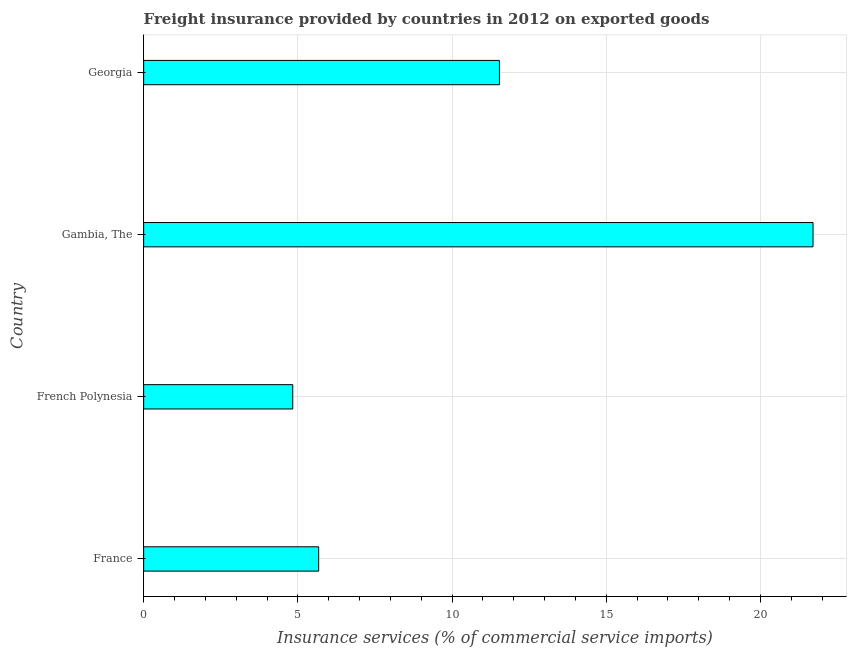Does the graph contain grids?
Give a very brief answer. Yes. What is the title of the graph?
Keep it short and to the point. Freight insurance provided by countries in 2012 on exported goods . What is the label or title of the X-axis?
Provide a succinct answer. Insurance services (% of commercial service imports). What is the freight insurance in France?
Your response must be concise. 5.68. Across all countries, what is the maximum freight insurance?
Keep it short and to the point. 21.7. Across all countries, what is the minimum freight insurance?
Your answer should be compact. 4.83. In which country was the freight insurance maximum?
Provide a short and direct response. Gambia, The. In which country was the freight insurance minimum?
Provide a succinct answer. French Polynesia. What is the sum of the freight insurance?
Your answer should be compact. 43.75. What is the difference between the freight insurance in French Polynesia and Georgia?
Ensure brevity in your answer.  -6.7. What is the average freight insurance per country?
Make the answer very short. 10.94. What is the median freight insurance?
Your answer should be compact. 8.61. What is the ratio of the freight insurance in French Polynesia to that in Georgia?
Give a very brief answer. 0.42. Is the difference between the freight insurance in French Polynesia and Georgia greater than the difference between any two countries?
Provide a succinct answer. No. What is the difference between the highest and the second highest freight insurance?
Your answer should be compact. 10.17. Is the sum of the freight insurance in Gambia, The and Georgia greater than the maximum freight insurance across all countries?
Provide a short and direct response. Yes. What is the difference between the highest and the lowest freight insurance?
Offer a very short reply. 16.87. In how many countries, is the freight insurance greater than the average freight insurance taken over all countries?
Provide a succinct answer. 2. How many bars are there?
Your response must be concise. 4. How many countries are there in the graph?
Offer a terse response. 4. Are the values on the major ticks of X-axis written in scientific E-notation?
Give a very brief answer. No. What is the Insurance services (% of commercial service imports) in France?
Offer a terse response. 5.68. What is the Insurance services (% of commercial service imports) in French Polynesia?
Keep it short and to the point. 4.83. What is the Insurance services (% of commercial service imports) of Gambia, The?
Your answer should be compact. 21.7. What is the Insurance services (% of commercial service imports) in Georgia?
Your answer should be very brief. 11.54. What is the difference between the Insurance services (% of commercial service imports) in France and French Polynesia?
Your answer should be very brief. 0.84. What is the difference between the Insurance services (% of commercial service imports) in France and Gambia, The?
Your response must be concise. -16.03. What is the difference between the Insurance services (% of commercial service imports) in France and Georgia?
Offer a terse response. -5.86. What is the difference between the Insurance services (% of commercial service imports) in French Polynesia and Gambia, The?
Keep it short and to the point. -16.87. What is the difference between the Insurance services (% of commercial service imports) in French Polynesia and Georgia?
Ensure brevity in your answer.  -6.7. What is the difference between the Insurance services (% of commercial service imports) in Gambia, The and Georgia?
Offer a terse response. 10.17. What is the ratio of the Insurance services (% of commercial service imports) in France to that in French Polynesia?
Offer a very short reply. 1.17. What is the ratio of the Insurance services (% of commercial service imports) in France to that in Gambia, The?
Provide a succinct answer. 0.26. What is the ratio of the Insurance services (% of commercial service imports) in France to that in Georgia?
Keep it short and to the point. 0.49. What is the ratio of the Insurance services (% of commercial service imports) in French Polynesia to that in Gambia, The?
Provide a succinct answer. 0.22. What is the ratio of the Insurance services (% of commercial service imports) in French Polynesia to that in Georgia?
Provide a succinct answer. 0.42. What is the ratio of the Insurance services (% of commercial service imports) in Gambia, The to that in Georgia?
Your response must be concise. 1.88. 